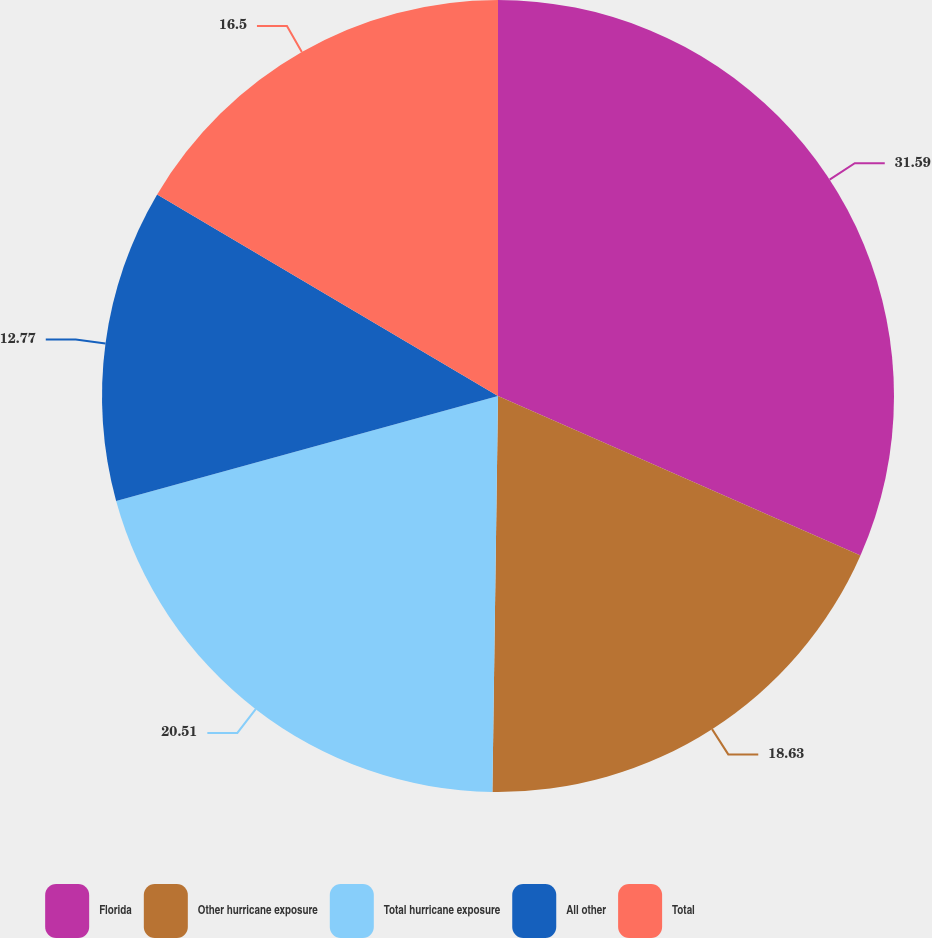Convert chart. <chart><loc_0><loc_0><loc_500><loc_500><pie_chart><fcel>Florida<fcel>Other hurricane exposure<fcel>Total hurricane exposure<fcel>All other<fcel>Total<nl><fcel>31.6%<fcel>18.63%<fcel>20.51%<fcel>12.77%<fcel>16.5%<nl></chart> 